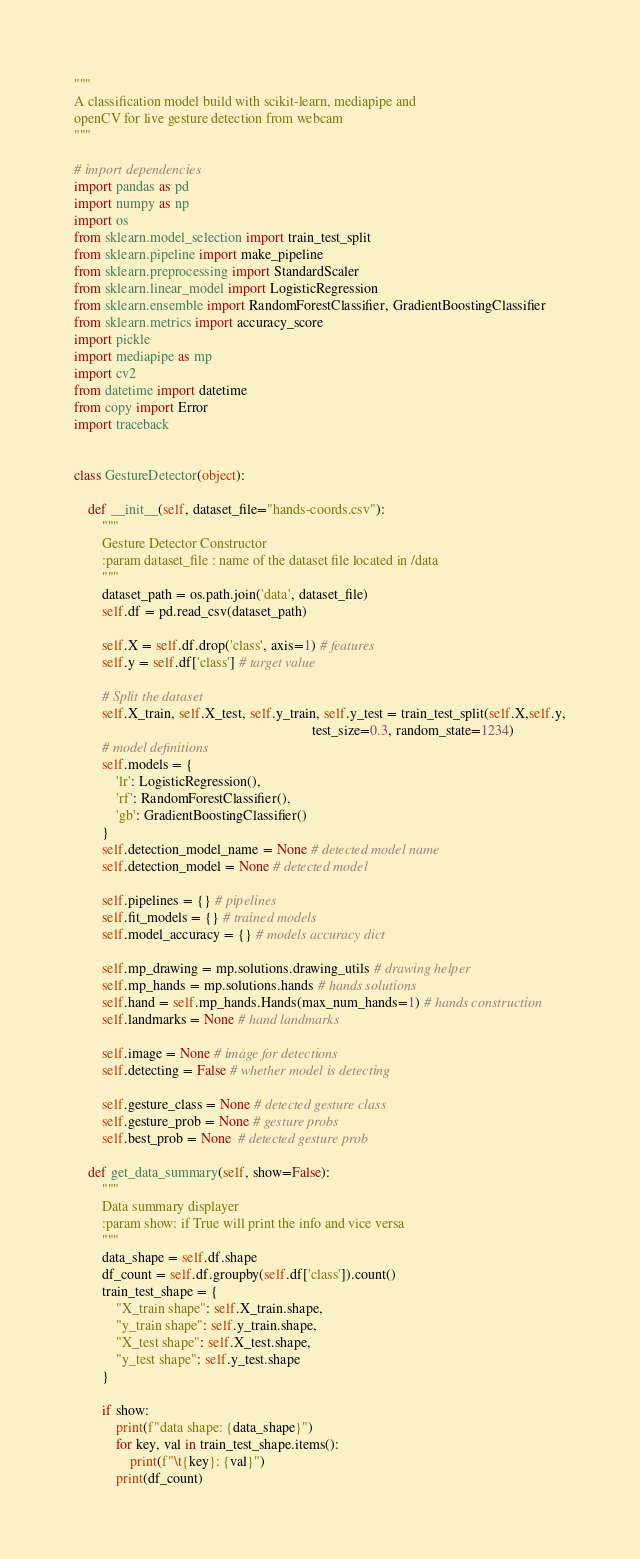<code> <loc_0><loc_0><loc_500><loc_500><_Python_>"""
A classification model build with scikit-learn, mediapipe and 
openCV for live gesture detection from webcam
"""

# import dependencies
import pandas as pd
import numpy as np
import os
from sklearn.model_selection import train_test_split
from sklearn.pipeline import make_pipeline
from sklearn.preprocessing import StandardScaler
from sklearn.linear_model import LogisticRegression
from sklearn.ensemble import RandomForestClassifier, GradientBoostingClassifier
from sklearn.metrics import accuracy_score
import pickle
import mediapipe as mp 
import cv2
from datetime import datetime
from copy import Error
import traceback


class GestureDetector(object):

    def __init__(self, dataset_file="hands-coords.csv"):
        """
        Gesture Detector Constructor
        :param dataset_file : name of the dataset file located in /data 
        """
        dataset_path = os.path.join('data', dataset_file)
        self.df = pd.read_csv(dataset_path)

        self.X = self.df.drop('class', axis=1) # features
        self.y = self.df['class'] # target value

        # Split the dataset
        self.X_train, self.X_test, self.y_train, self.y_test = train_test_split(self.X,self.y,
                                                                    test_size=0.3, random_state=1234)
        # model definitions
        self.models = {
            'lr': LogisticRegression(),
            'rf': RandomForestClassifier(),
            'gb': GradientBoostingClassifier()
        }
        self.detection_model_name = None # detected model name
        self.detection_model = None # detected model
        
        self.pipelines = {} # pipelines
        self.fit_models = {} # trained models
        self.model_accuracy = {} # models accuracy dict

        self.mp_drawing = mp.solutions.drawing_utils # drawing helper
        self.mp_hands = mp.solutions.hands # hands solutions
        self.hand = self.mp_hands.Hands(max_num_hands=1) # hands construction
        self.landmarks = None # hand landmarks

        self.image = None # image for detections
        self.detecting = False # whether model is detecting
        
        self.gesture_class = None # detected gesture class
        self.gesture_prob = None # gesture probs
        self.best_prob = None  # detected gesture prob

    def get_data_summary(self, show=False):
        """
        Data summary displayer
        :param show: if True will print the info and vice versa 
        """
        data_shape = self.df.shape
        df_count = self.df.groupby(self.df['class']).count()
        train_test_shape = {
            "X_train shape": self.X_train.shape,
            "y_train shape": self.y_train.shape,
            "X_test shape": self.X_test.shape,
            "y_test shape": self.y_test.shape
        }

        if show:
            print(f"data shape: {data_shape}")
            for key, val in train_test_shape.items():
                print(f"\t{key}: {val}")     
            print(df_count)
</code> 